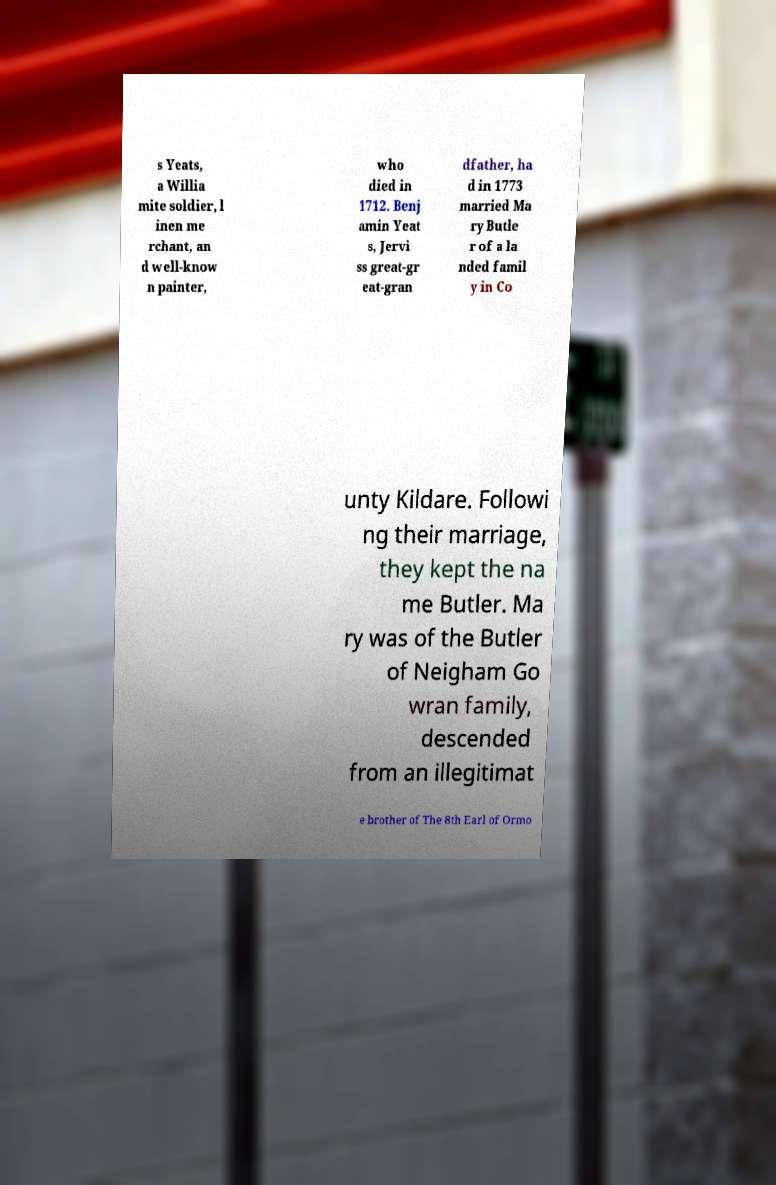For documentation purposes, I need the text within this image transcribed. Could you provide that? s Yeats, a Willia mite soldier, l inen me rchant, an d well-know n painter, who died in 1712. Benj amin Yeat s, Jervi ss great-gr eat-gran dfather, ha d in 1773 married Ma ry Butle r of a la nded famil y in Co unty Kildare. Followi ng their marriage, they kept the na me Butler. Ma ry was of the Butler of Neigham Go wran family, descended from an illegitimat e brother of The 8th Earl of Ormo 